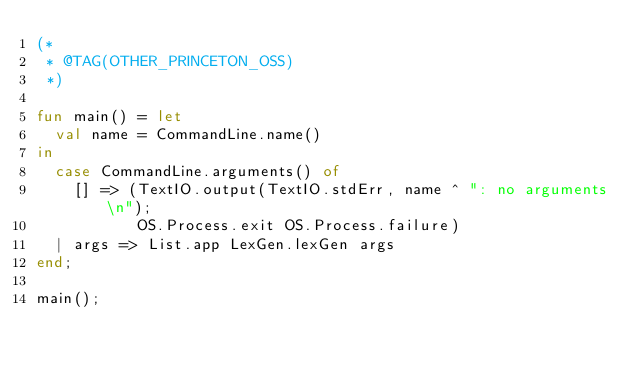Convert code to text. <code><loc_0><loc_0><loc_500><loc_500><_SML_>(*
 * @TAG(OTHER_PRINCETON_OSS)
 *)

fun main() = let
  val name = CommandLine.name()
in
  case CommandLine.arguments() of
    [] => (TextIO.output(TextIO.stdErr, name ^ ": no arguments\n");
           OS.Process.exit OS.Process.failure)
  | args => List.app LexGen.lexGen args
end;

main();


</code> 